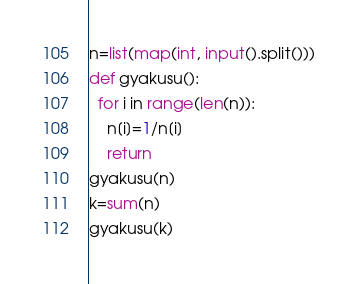Convert code to text. <code><loc_0><loc_0><loc_500><loc_500><_Python_>n=list(map(int, input().split()))
def gyakusu():
  for i in range(len(n)):
    n[i]=1/n[i]
    return
gyakusu(n)
k=sum(n)
gyakusu(k)</code> 